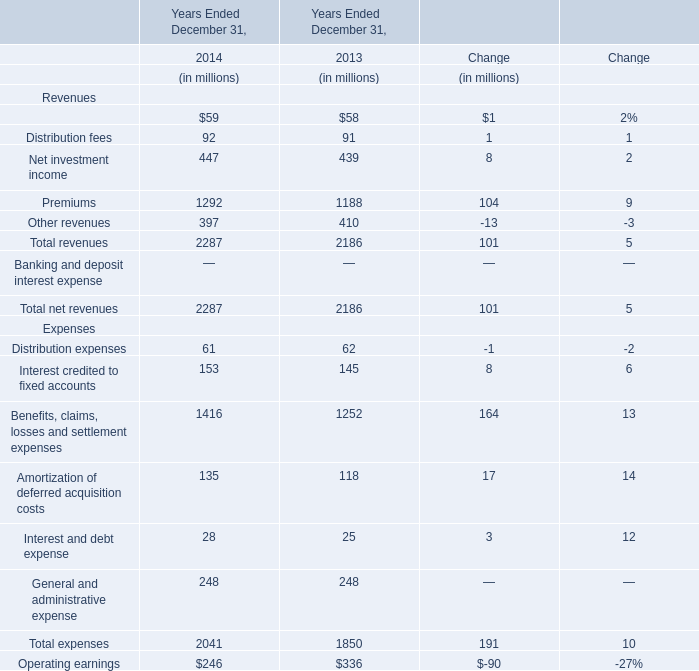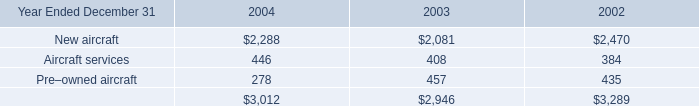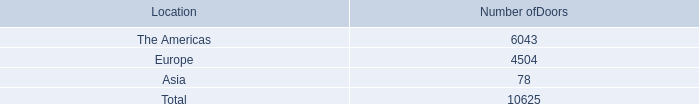What is the average amount of Europe of Number ofDoors, and New aircraft of 2003 ? 
Computations: ((4504.0 + 2081.0) / 2)
Answer: 3292.5. 